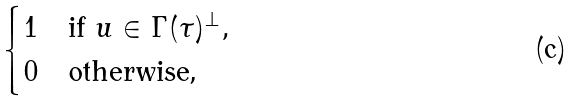<formula> <loc_0><loc_0><loc_500><loc_500>\begin{cases} 1 & \text {if } u \in \Gamma ( \tau ) ^ { \perp } , \\ 0 & \text {otherwise,} \end{cases}</formula> 